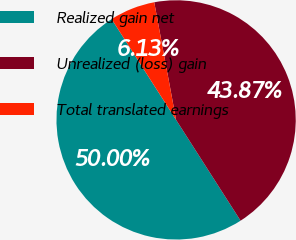<chart> <loc_0><loc_0><loc_500><loc_500><pie_chart><fcel>Realized gain net<fcel>Unrealized (loss) gain<fcel>Total translated earnings<nl><fcel>50.0%<fcel>43.87%<fcel>6.13%<nl></chart> 